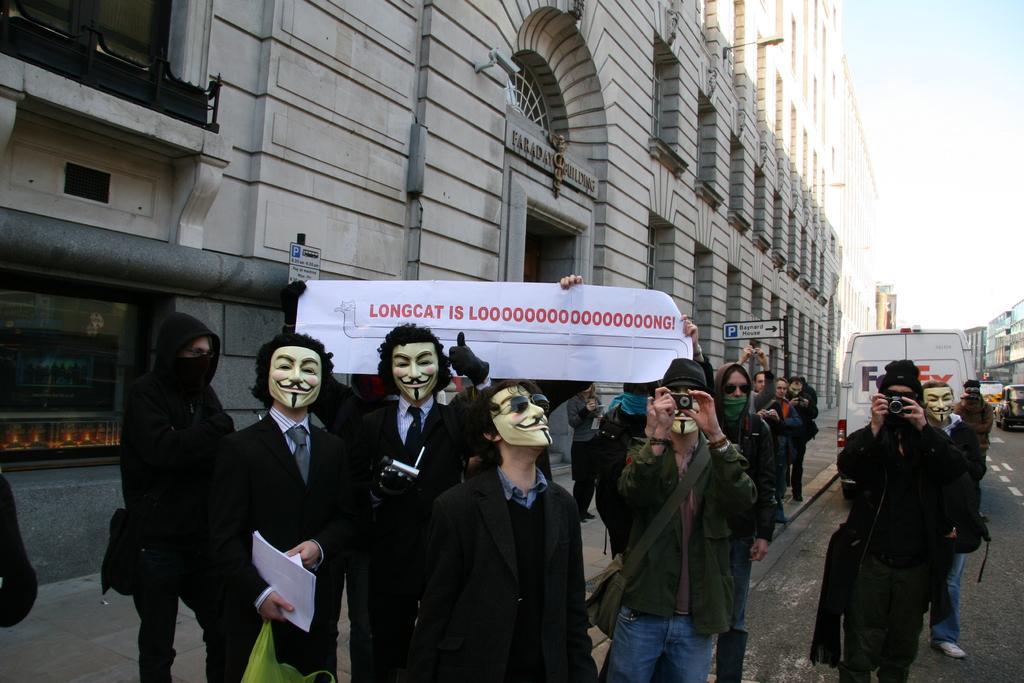Can you describe this image briefly? In the picture we can see some people are standing with a different costumes and some people are holding cameras and capturing some pictures and behind them, we can see a van which is white in color and besides the road we can see a building with windows and a glass window and in the background also we can see some houses and a sky. 